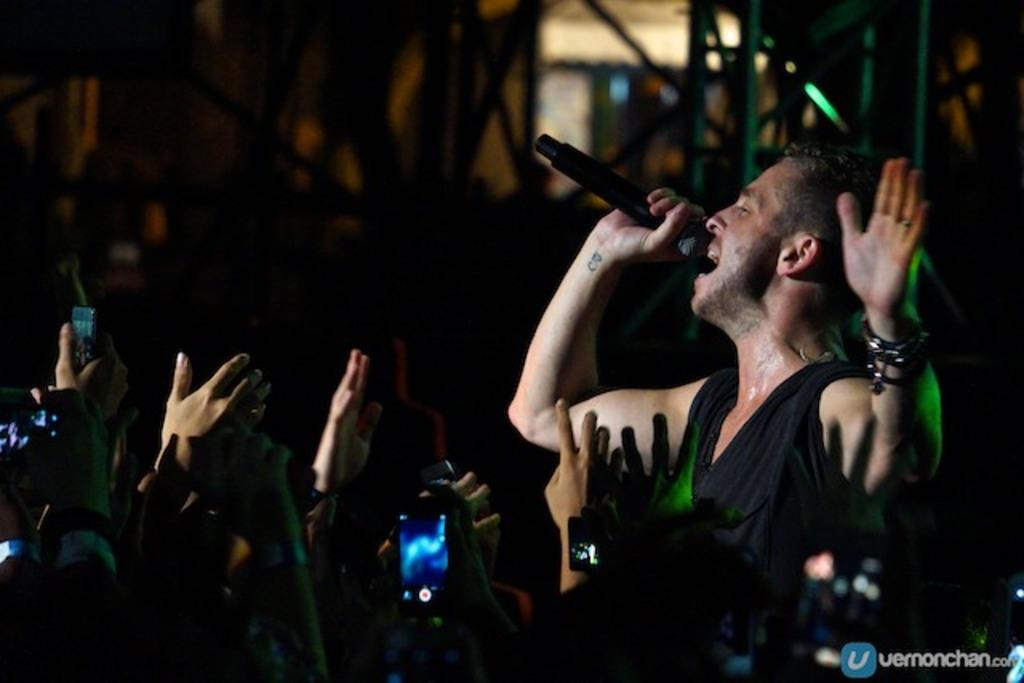How many people are in the image? There are people in the image. What is the man holding in the image? The man is holding a microphone. What is the man doing with the microphone? The man is singing a song. Where is the maid wearing a crown in the image? There is no maid or crown present in the image. What type of twist can be seen in the image? There is no twist present in the image. 